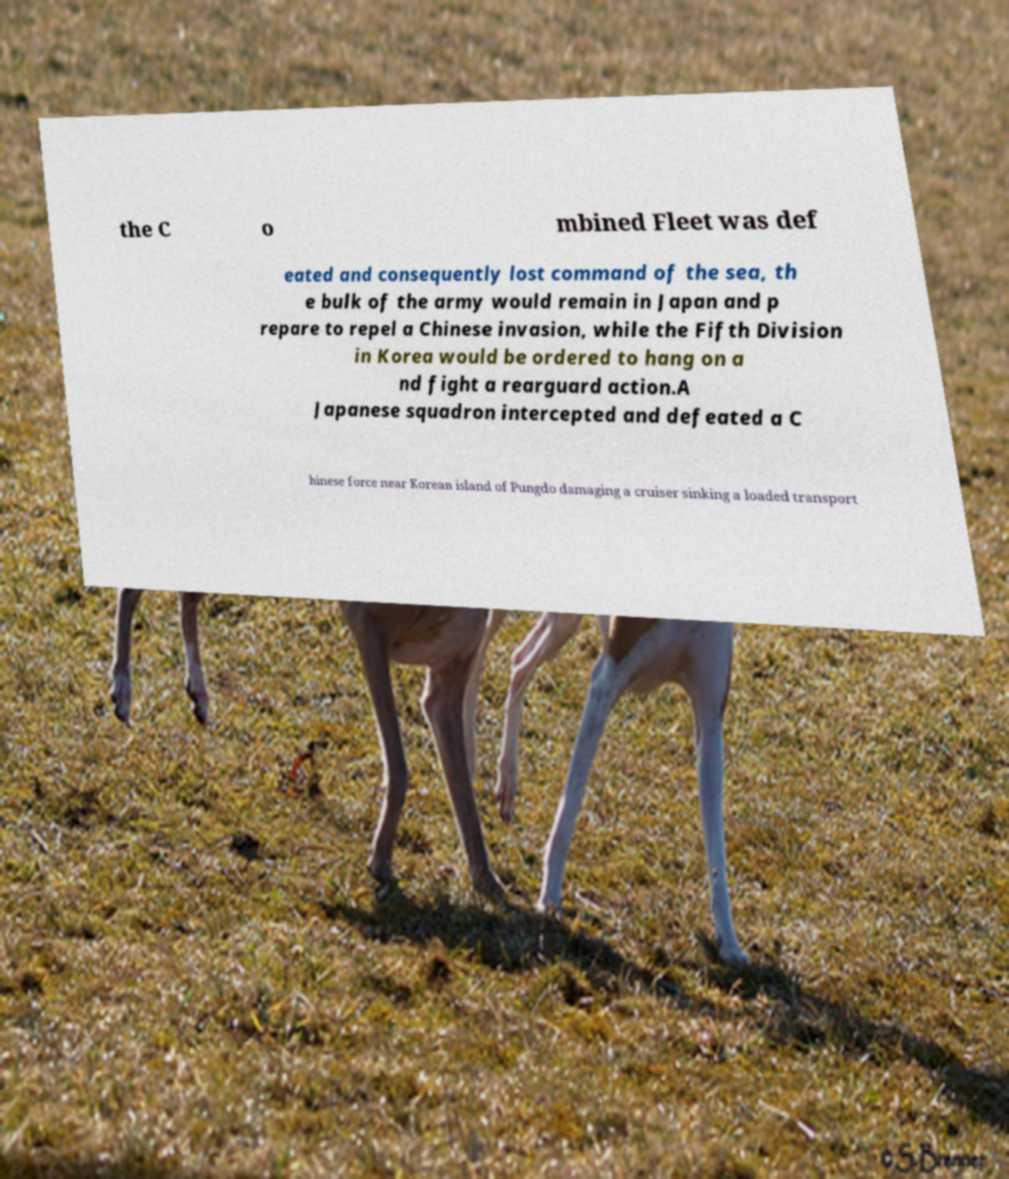Can you read and provide the text displayed in the image?This photo seems to have some interesting text. Can you extract and type it out for me? the C o mbined Fleet was def eated and consequently lost command of the sea, th e bulk of the army would remain in Japan and p repare to repel a Chinese invasion, while the Fifth Division in Korea would be ordered to hang on a nd fight a rearguard action.A Japanese squadron intercepted and defeated a C hinese force near Korean island of Pungdo damaging a cruiser sinking a loaded transport 